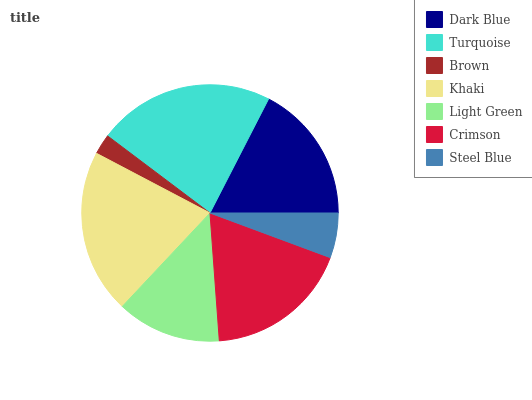Is Brown the minimum?
Answer yes or no. Yes. Is Turquoise the maximum?
Answer yes or no. Yes. Is Turquoise the minimum?
Answer yes or no. No. Is Brown the maximum?
Answer yes or no. No. Is Turquoise greater than Brown?
Answer yes or no. Yes. Is Brown less than Turquoise?
Answer yes or no. Yes. Is Brown greater than Turquoise?
Answer yes or no. No. Is Turquoise less than Brown?
Answer yes or no. No. Is Dark Blue the high median?
Answer yes or no. Yes. Is Dark Blue the low median?
Answer yes or no. Yes. Is Turquoise the high median?
Answer yes or no. No. Is Crimson the low median?
Answer yes or no. No. 